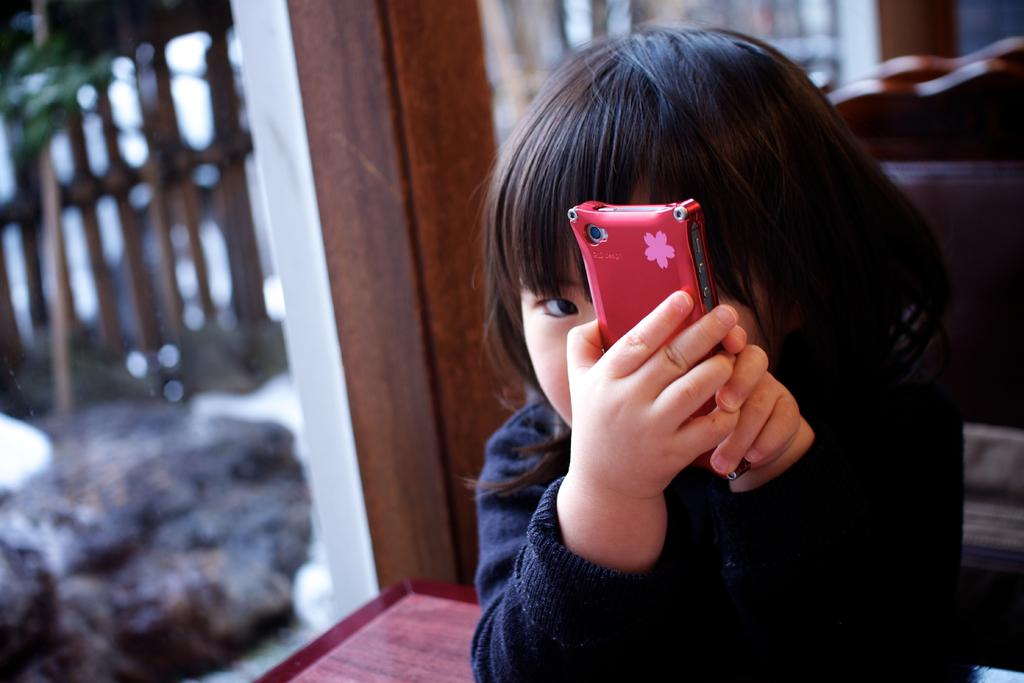Who is the main subject in the image? There is a girl in the image. What is the girl holding in the image? The girl is holding a mobile. What can be seen in the background of the image? There are pillars and a table visible in the background of the image. How many balls are visible in the image? There are no balls present in the image. What type of kitten can be seen playing with a flower in the image? There is no kitten or flower present in the image. 